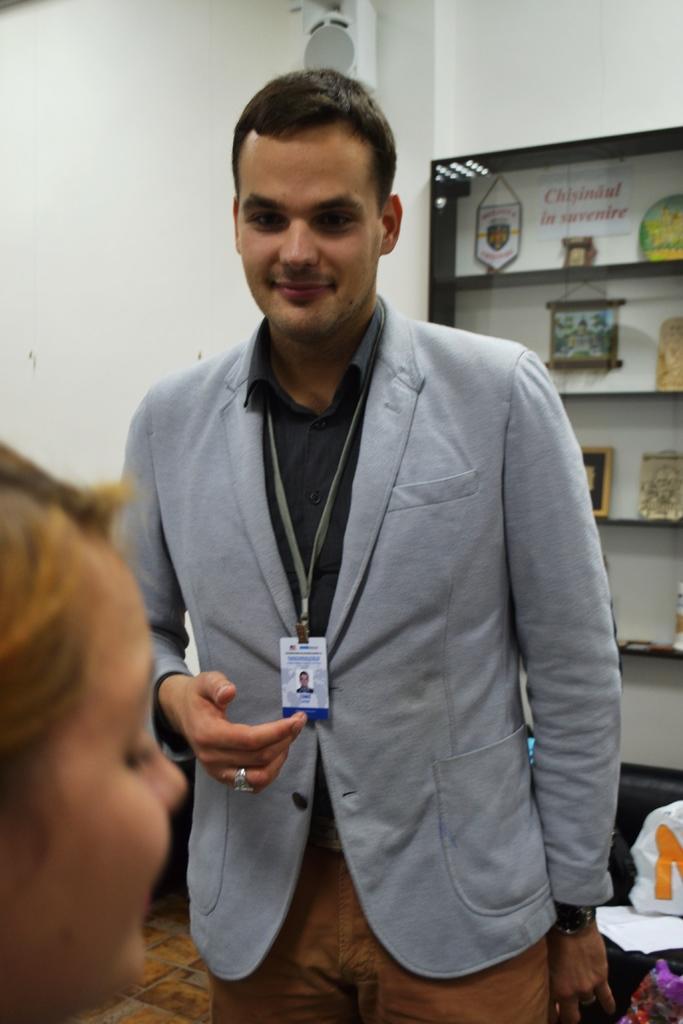How would you summarize this image in a sentence or two? This image consists of a man wearing a gray suit along with an ID card. On the left, we can see a woman. In the background, there is a rack in which there are frames. On the left, there is a wall in white color. 